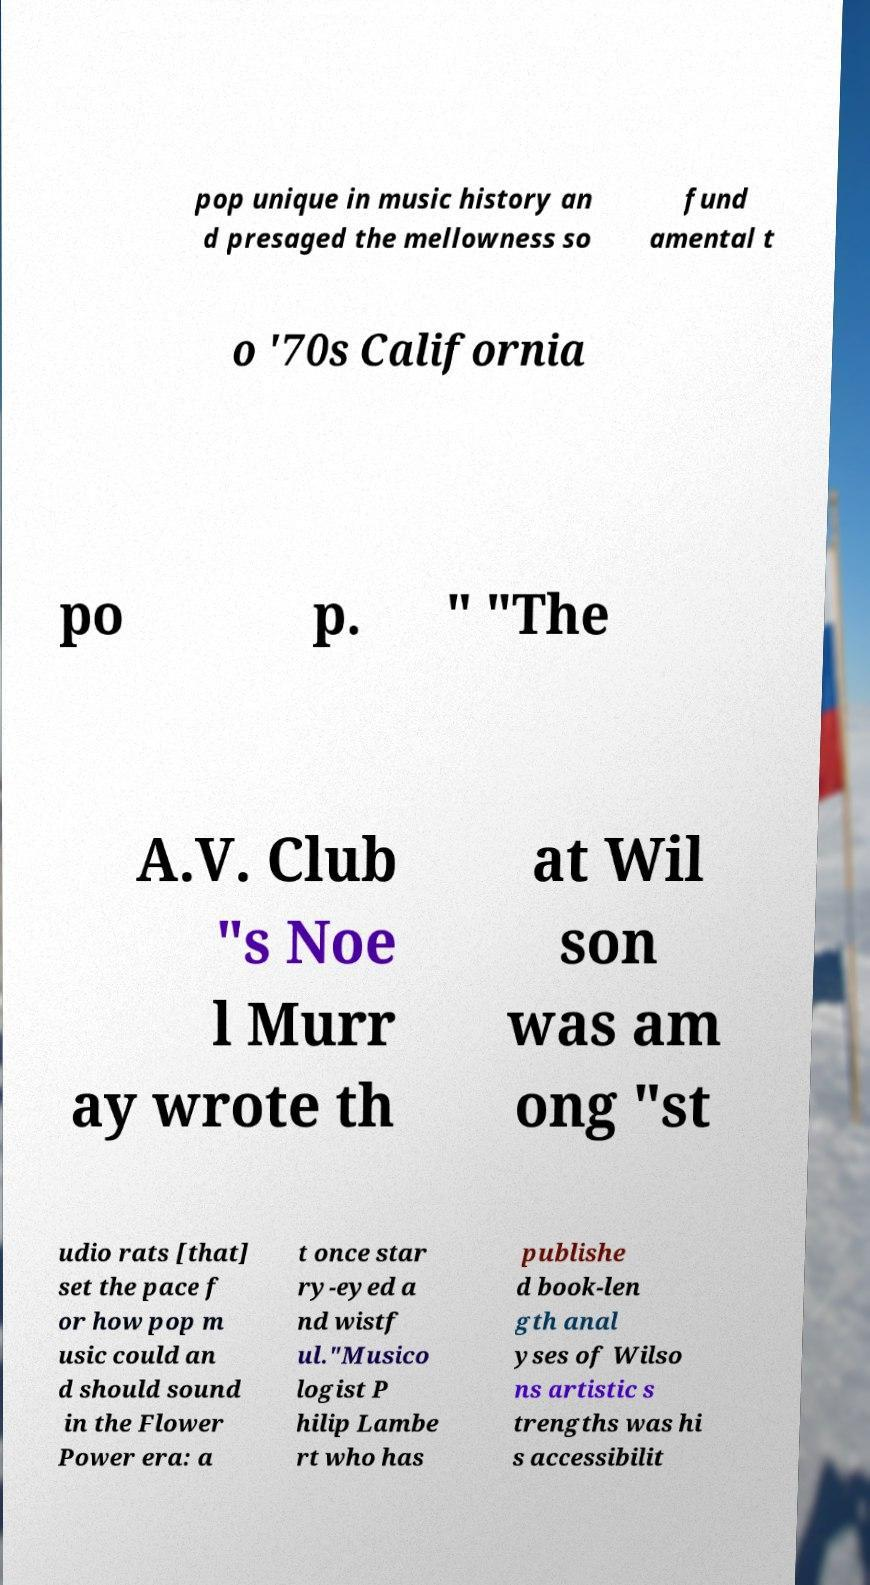Can you accurately transcribe the text from the provided image for me? pop unique in music history an d presaged the mellowness so fund amental t o '70s California po p. " "The A.V. Club "s Noe l Murr ay wrote th at Wil son was am ong "st udio rats [that] set the pace f or how pop m usic could an d should sound in the Flower Power era: a t once star ry-eyed a nd wistf ul."Musico logist P hilip Lambe rt who has publishe d book-len gth anal yses of Wilso ns artistic s trengths was hi s accessibilit 